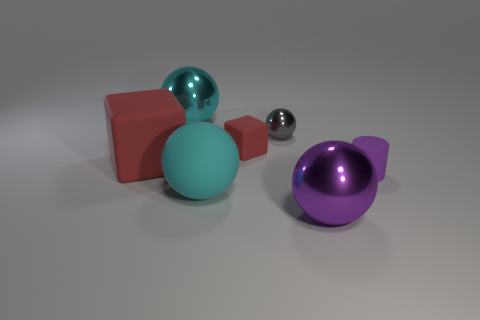How many cyan spheres must be subtracted to get 1 cyan spheres? 1 Subtract 1 spheres. How many spheres are left? 3 Add 2 large yellow metallic objects. How many objects exist? 9 Subtract all blocks. How many objects are left? 5 Subtract all large yellow matte things. Subtract all rubber objects. How many objects are left? 3 Add 4 metal things. How many metal things are left? 7 Add 7 tiny red cubes. How many tiny red cubes exist? 8 Subtract 0 brown blocks. How many objects are left? 7 